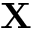Convert formula to latex. <formula><loc_0><loc_0><loc_500><loc_500>X</formula> 